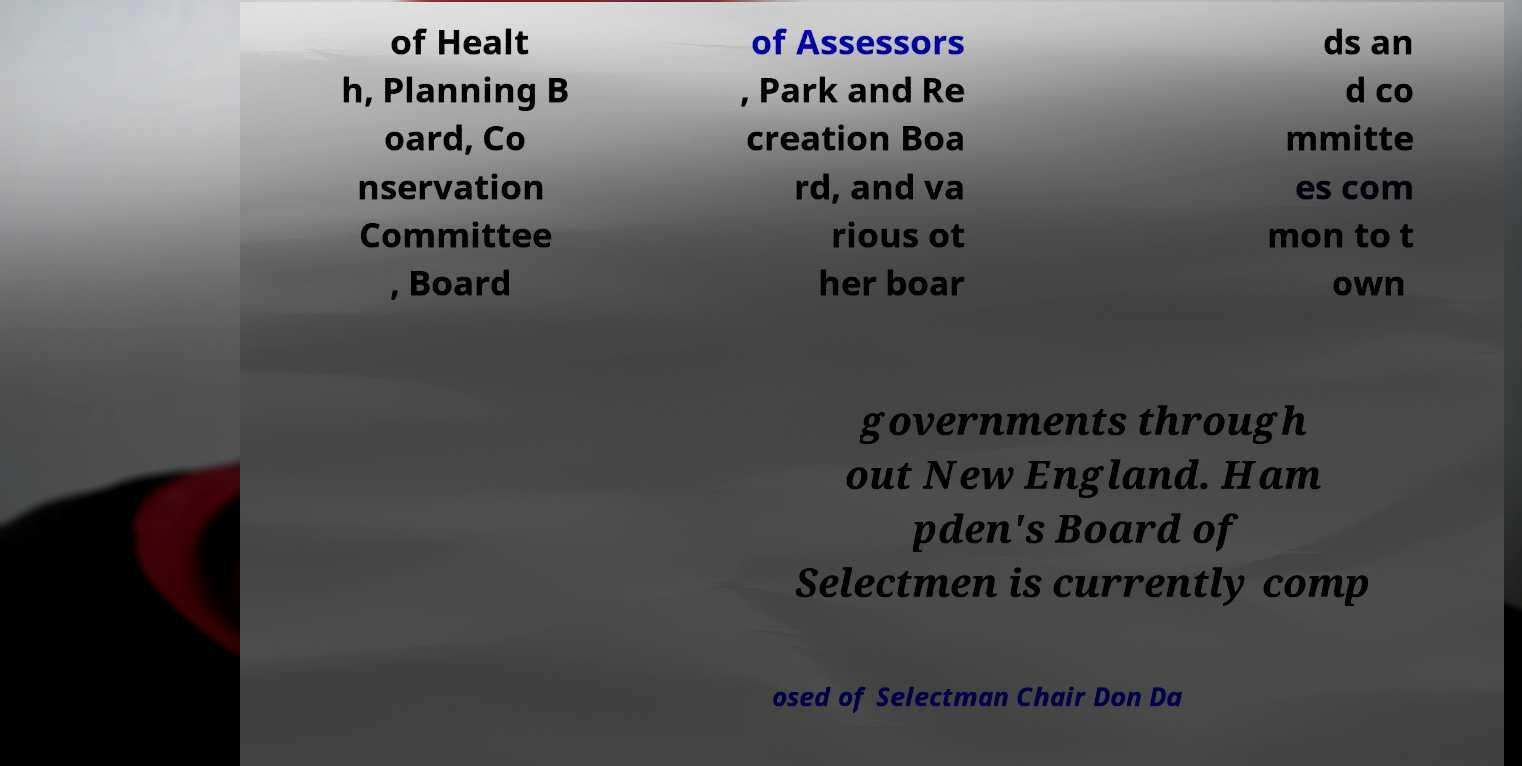Can you read and provide the text displayed in the image?This photo seems to have some interesting text. Can you extract and type it out for me? of Healt h, Planning B oard, Co nservation Committee , Board of Assessors , Park and Re creation Boa rd, and va rious ot her boar ds an d co mmitte es com mon to t own governments through out New England. Ham pden's Board of Selectmen is currently comp osed of Selectman Chair Don Da 